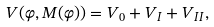Convert formula to latex. <formula><loc_0><loc_0><loc_500><loc_500>V ( \varphi , M ( \varphi ) ) = V _ { 0 } + V _ { I } + V _ { I I } ,</formula> 